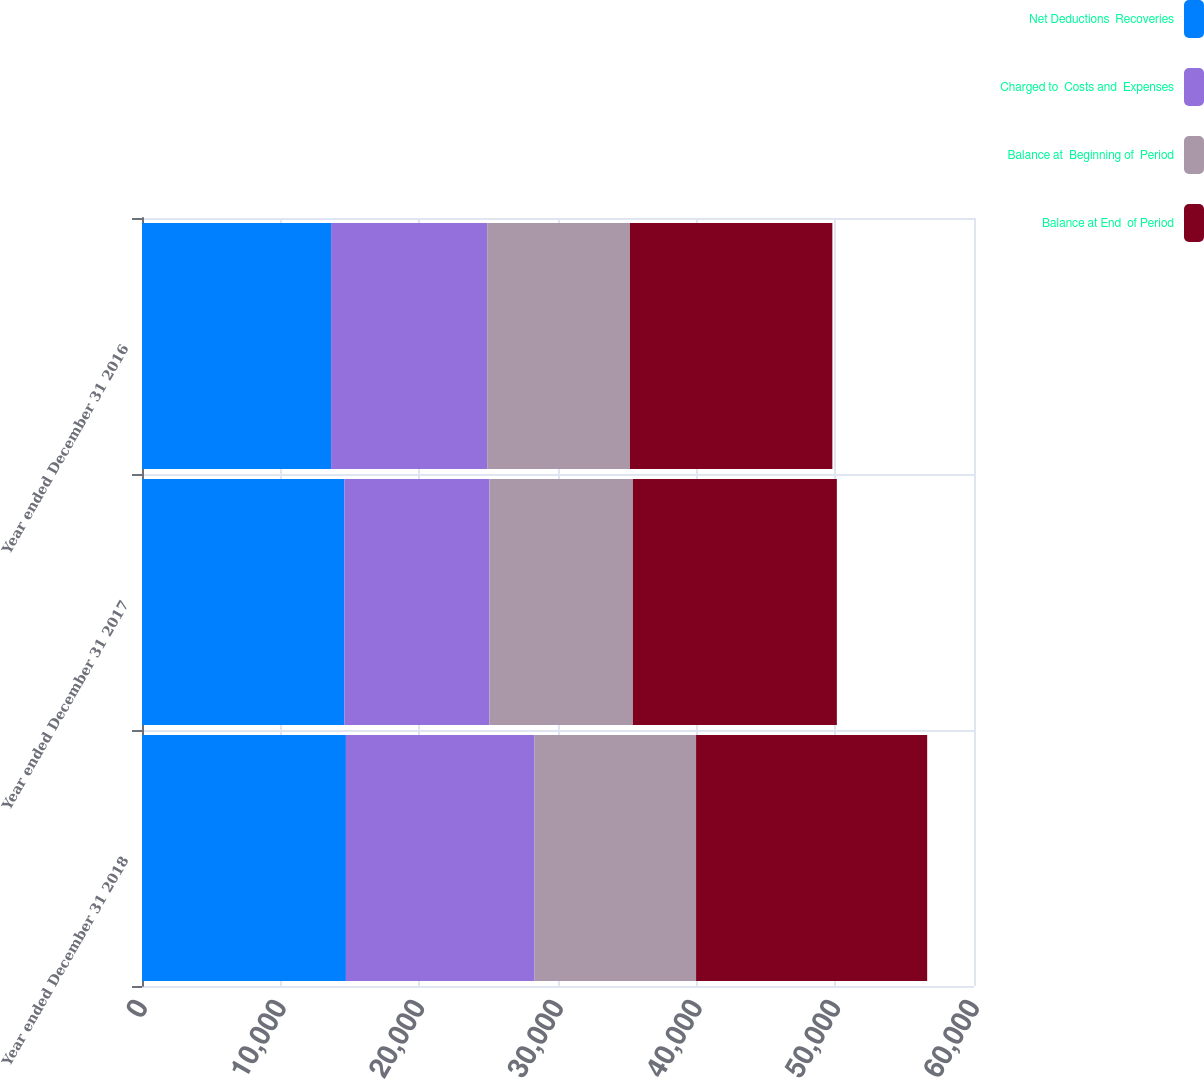<chart> <loc_0><loc_0><loc_500><loc_500><stacked_bar_chart><ecel><fcel>Year ended December 31 2018<fcel>Year ended December 31 2017<fcel>Year ended December 31 2016<nl><fcel>Net Deductions  Recoveries<fcel>14706<fcel>14600<fcel>13636<nl><fcel>Charged to  Costs and  Expenses<fcel>13606<fcel>10455<fcel>11257<nl><fcel>Balance at  Beginning of  Period<fcel>11646<fcel>10349<fcel>10293<nl><fcel>Balance at End  of Period<fcel>16666<fcel>14706<fcel>14600<nl></chart> 